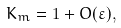Convert formula to latex. <formula><loc_0><loc_0><loc_500><loc_500>K _ { m } = 1 + O ( \varepsilon ) ,</formula> 